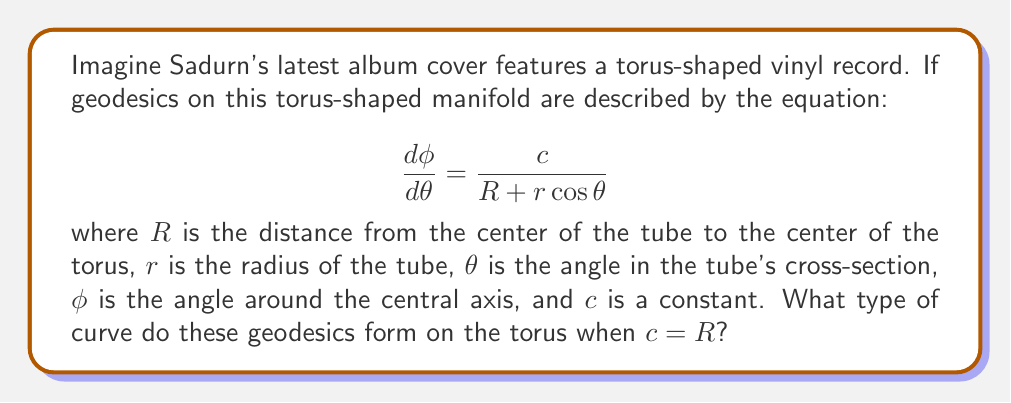Can you solve this math problem? Let's approach this step-by-step:

1) The equation for geodesics on a torus is given by:

   $$ \frac{d\phi}{d\theta} = \frac{c}{R + r\cos\theta} $$

2) We're told that $c = R$ in this case. Substituting this:

   $$ \frac{d\phi}{d\theta} = \frac{R}{R + r\cos\theta} $$

3) To understand what this means geometrically, let's consider the extreme cases:

   a) When $\theta = 0$ or $2\pi$ (outer equator of the torus), $\cos\theta = 1$:
      $$ \frac{d\phi}{d\theta} = \frac{R}{R + r} < 1 $$

   b) When $\theta = \pi$ (inner equator of the torus), $\cos\theta = -1$:
      $$ \frac{d\phi}{d\theta} = \frac{R}{R - r} > 1 $$

4) This means that as $\theta$ increases from 0 to $2\pi$, $\frac{d\phi}{d\theta}$ oscillates between these two values, always remaining positive.

5) Geometrically, this describes a curve that winds around the torus, moving faster in the $\phi$ direction on the inner part of the torus and slower on the outer part.

6) Such a curve that wraps around both the major and minor circumferences of the torus without closing is known as a Villarceau circle.

Therefore, when $c = R$, the geodesics form Villarceau circles on the torus.
Answer: Villarceau circles 